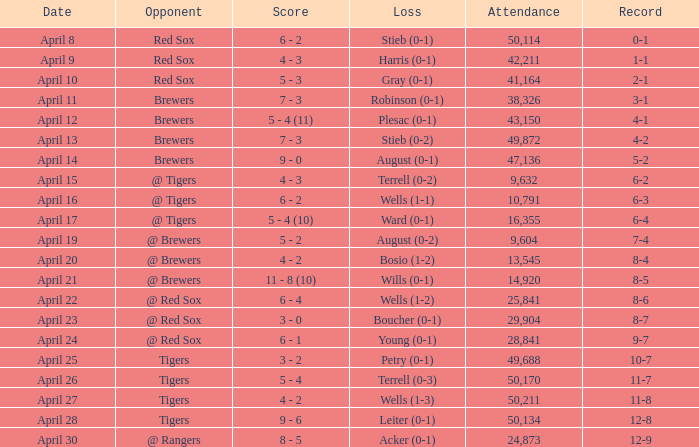Which adversary has a turnout exceeding 29,904 and a 11-8 record? Tigers. 